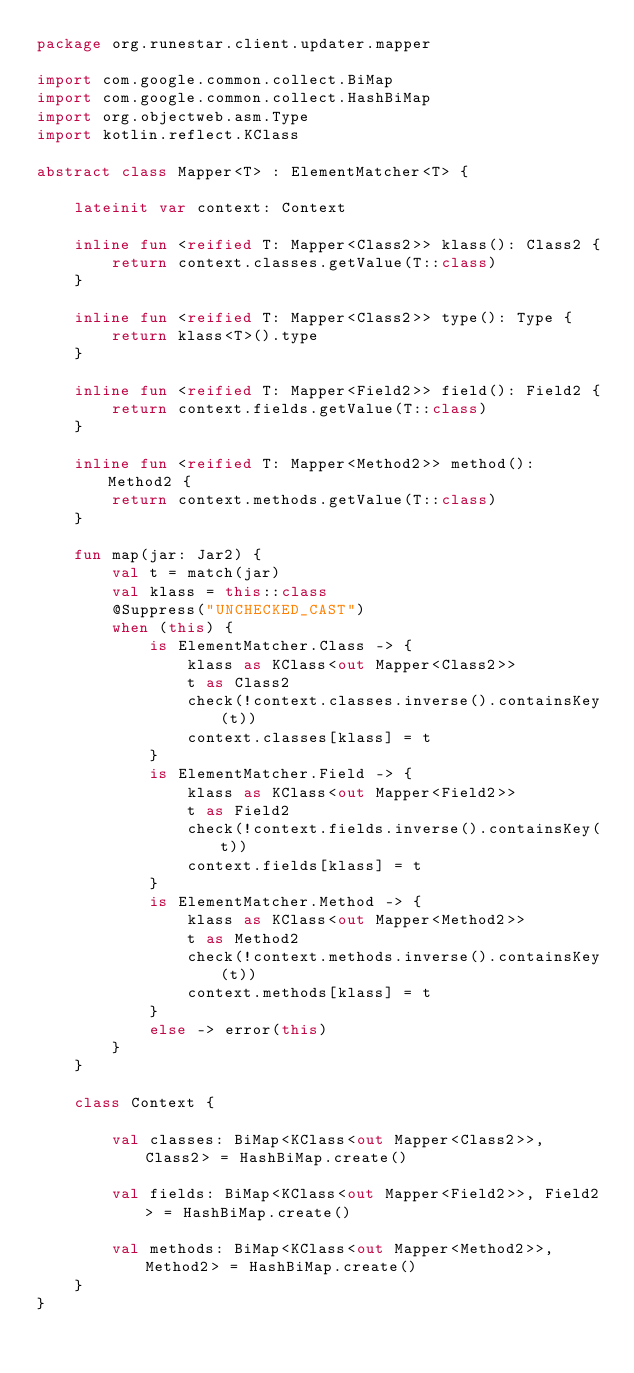Convert code to text. <code><loc_0><loc_0><loc_500><loc_500><_Kotlin_>package org.runestar.client.updater.mapper

import com.google.common.collect.BiMap
import com.google.common.collect.HashBiMap
import org.objectweb.asm.Type
import kotlin.reflect.KClass

abstract class Mapper<T> : ElementMatcher<T> {

    lateinit var context: Context

    inline fun <reified T: Mapper<Class2>> klass(): Class2 {
        return context.classes.getValue(T::class)
    }

    inline fun <reified T: Mapper<Class2>> type(): Type {
        return klass<T>().type
    }

    inline fun <reified T: Mapper<Field2>> field(): Field2 {
        return context.fields.getValue(T::class)
    }

    inline fun <reified T: Mapper<Method2>> method(): Method2 {
        return context.methods.getValue(T::class)
    }

    fun map(jar: Jar2) {
        val t = match(jar)
        val klass = this::class
        @Suppress("UNCHECKED_CAST")
        when (this) {
            is ElementMatcher.Class -> {
                klass as KClass<out Mapper<Class2>>
                t as Class2
                check(!context.classes.inverse().containsKey(t))
                context.classes[klass] = t
            }
            is ElementMatcher.Field -> {
                klass as KClass<out Mapper<Field2>>
                t as Field2
                check(!context.fields.inverse().containsKey(t))
                context.fields[klass] = t
            }
            is ElementMatcher.Method -> {
                klass as KClass<out Mapper<Method2>>
                t as Method2
                check(!context.methods.inverse().containsKey(t))
                context.methods[klass] = t
            }
            else -> error(this)
        }
    }

    class Context {

        val classes: BiMap<KClass<out Mapper<Class2>>, Class2> = HashBiMap.create()

        val fields: BiMap<KClass<out Mapper<Field2>>, Field2> = HashBiMap.create()

        val methods: BiMap<KClass<out Mapper<Method2>>, Method2> = HashBiMap.create()
    }
}

</code> 